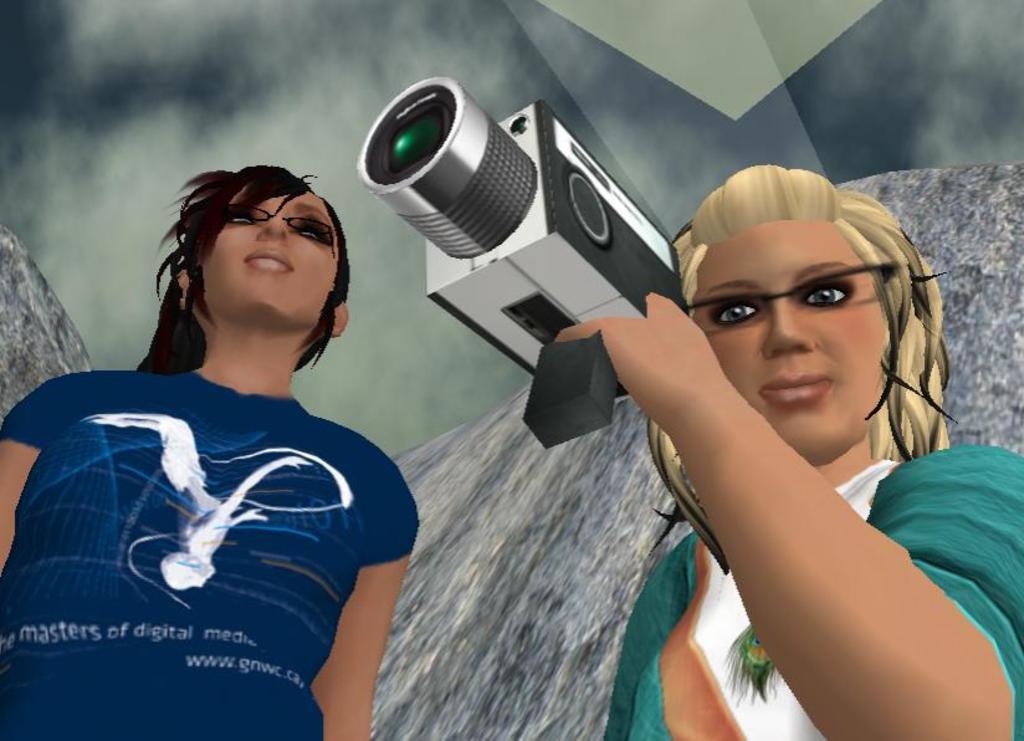Can you describe this image briefly? This is an animated picture. Here we can see two women and they have spectacles. She is holding a camera with her hand. 